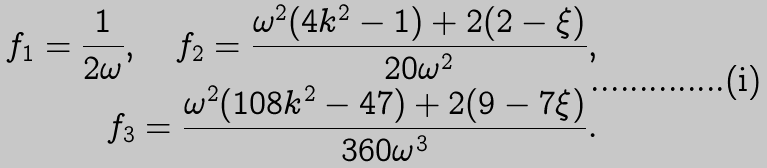Convert formula to latex. <formula><loc_0><loc_0><loc_500><loc_500>f _ { 1 } = \frac { 1 } { 2 \omega } , \quad f _ { 2 } = \frac { \omega ^ { 2 } ( 4 k ^ { 2 } - 1 ) + 2 ( 2 - \xi ) } { 2 0 \omega ^ { 2 } } , \\ f _ { 3 } = \frac { \omega ^ { 2 } ( 1 0 8 k ^ { 2 } - 4 7 ) + 2 ( 9 - 7 \xi ) } { 3 6 0 \omega ^ { 3 } } .</formula> 